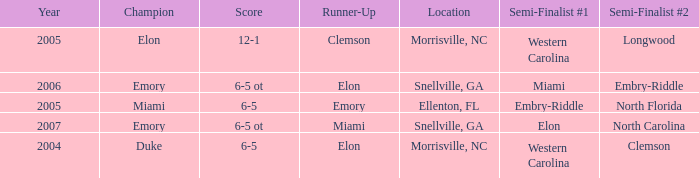When Embry-Riddle made it to the first semi finalist slot, list all the runners up. Emory. 